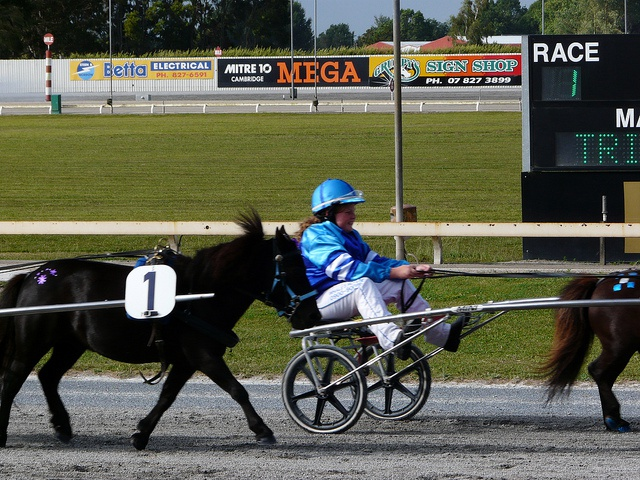Describe the objects in this image and their specific colors. I can see horse in black, white, darkgray, and gray tones, people in black, lavender, navy, and gray tones, and horse in black, olive, maroon, and gray tones in this image. 